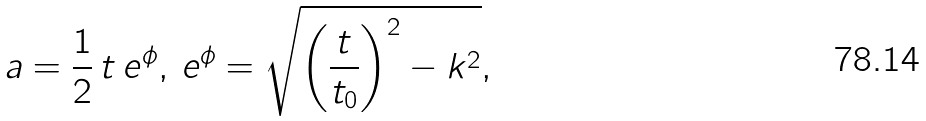Convert formula to latex. <formula><loc_0><loc_0><loc_500><loc_500>a = \frac { 1 } { 2 } \, t \, e ^ { \phi } , \, e ^ { \phi } = \sqrt { \left ( \frac { t } { t _ { 0 } } \right ) ^ { 2 } - k ^ { 2 } } ,</formula> 